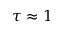<formula> <loc_0><loc_0><loc_500><loc_500>\tau \approx 1</formula> 